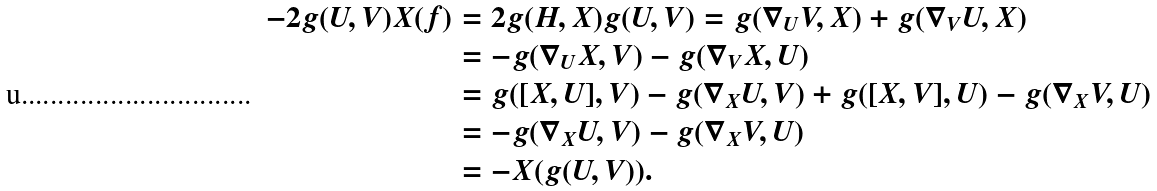Convert formula to latex. <formula><loc_0><loc_0><loc_500><loc_500>- 2 g ( U , V ) X ( f ) & = 2 g ( H , X ) g ( U , V ) = g ( \nabla _ { U } V , X ) + g ( \nabla _ { V } U , X ) \\ & = - g ( \nabla _ { U } X , V ) - g ( \nabla _ { V } X , U ) \\ & = g ( [ X , U ] , V ) - g ( \nabla _ { X } U , V ) + g ( [ X , V ] , U ) - g ( \nabla _ { X } V , U ) \\ & = - g ( \nabla _ { X } U , V ) - g ( \nabla _ { X } V , U ) \\ & = - X ( g ( U , V ) ) .</formula> 